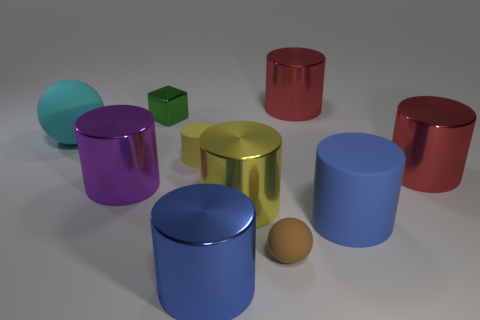Besides the cylinders, are there any other shapes present in the image? Yes, apart from the cylinders, there is also a solitary sphere, which has an orange or tan color and is positioned on the right side in front of the blue cylinder. Do the objects cast shadows, and if so, what can we infer about the light source? Each object casts a shadow, indicating that the light source is positioned above and slightly to the right from the perspective of the observer. The shadows help give a sense of the shapes' positions in three-dimensional space. 